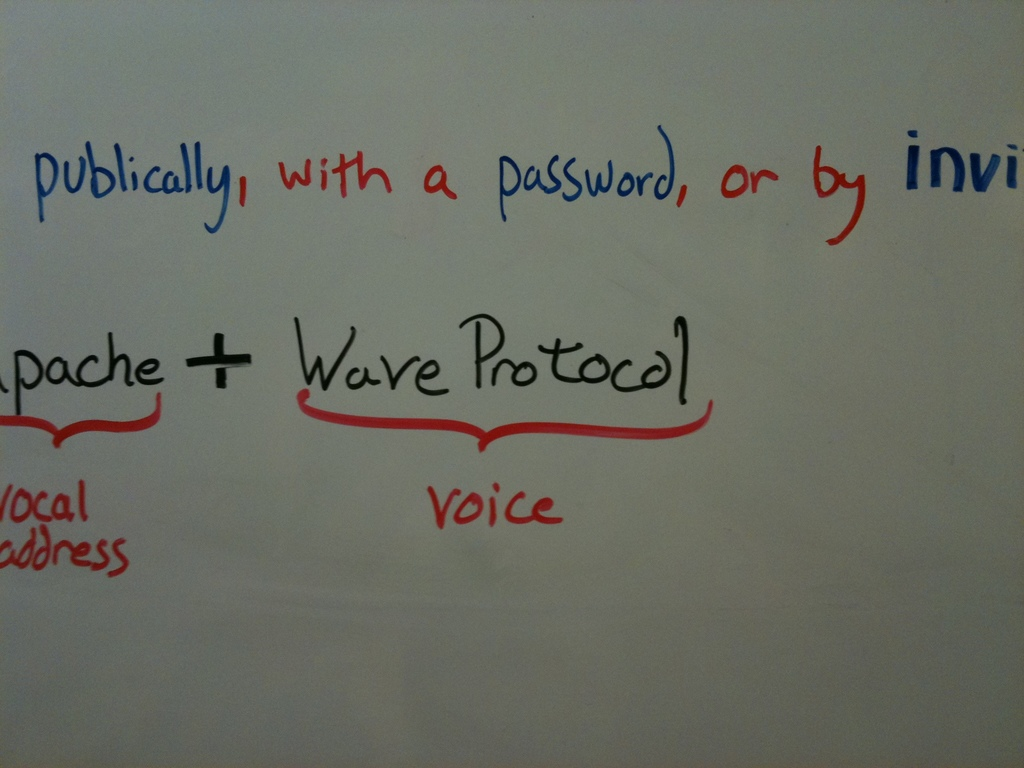How does the addition of 'voice' impact the functionality or appeal of the Apache Wave Protocol? Integrating 'voice' capabilities into the Apache Wave Protocol significantly enhances its functionality and appeal by allowing users to include voice communication in their real-time collaborations. This feature adds a personal touch and can boost the clarity and speed of communication, making discussions more dynamic and accessible, especially in contexts where quick decision-making or brainstorming is crucial. 